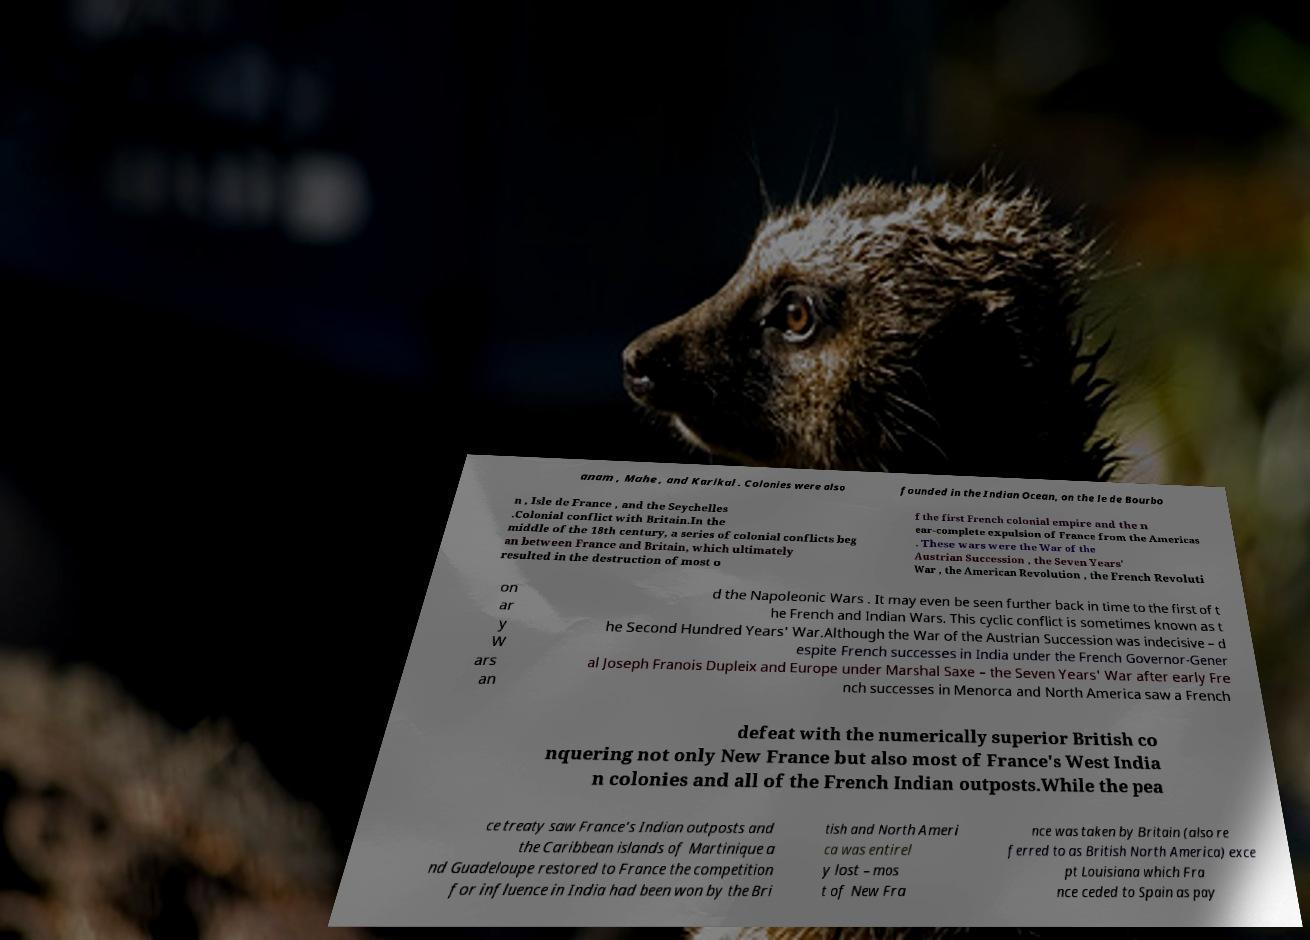I need the written content from this picture converted into text. Can you do that? anam , Mahe , and Karikal . Colonies were also founded in the Indian Ocean, on the le de Bourbo n , Isle de France , and the Seychelles .Colonial conflict with Britain.In the middle of the 18th century, a series of colonial conflicts beg an between France and Britain, which ultimately resulted in the destruction of most o f the first French colonial empire and the n ear-complete expulsion of France from the Americas . These wars were the War of the Austrian Succession , the Seven Years' War , the American Revolution , the French Revoluti on ar y W ars an d the Napoleonic Wars . It may even be seen further back in time to the first of t he French and Indian Wars. This cyclic conflict is sometimes known as t he Second Hundred Years' War.Although the War of the Austrian Succession was indecisive – d espite French successes in India under the French Governor-Gener al Joseph Franois Dupleix and Europe under Marshal Saxe – the Seven Years' War after early Fre nch successes in Menorca and North America saw a French defeat with the numerically superior British co nquering not only New France but also most of France's West India n colonies and all of the French Indian outposts.While the pea ce treaty saw France's Indian outposts and the Caribbean islands of Martinique a nd Guadeloupe restored to France the competition for influence in India had been won by the Bri tish and North Ameri ca was entirel y lost – mos t of New Fra nce was taken by Britain (also re ferred to as British North America) exce pt Louisiana which Fra nce ceded to Spain as pay 